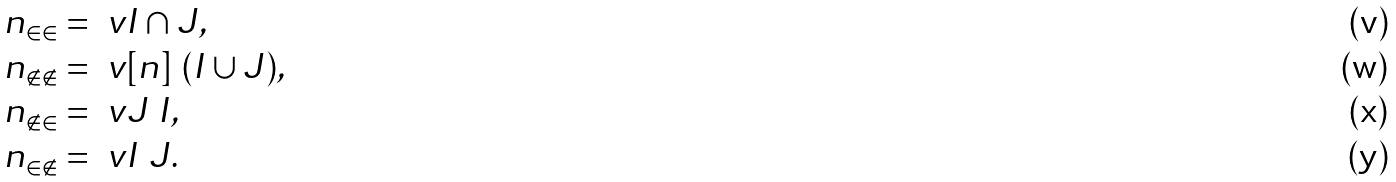<formula> <loc_0><loc_0><loc_500><loc_500>n _ { \in \in } & = \ v { I \cap J } , \\ n _ { \notin \notin } & = \ v { [ n ] \ ( I \cup J ) } , \\ n _ { \notin \in } & = \ v { J \ I } , \\ n _ { \in \notin } & = \ v { I \ J } .</formula> 